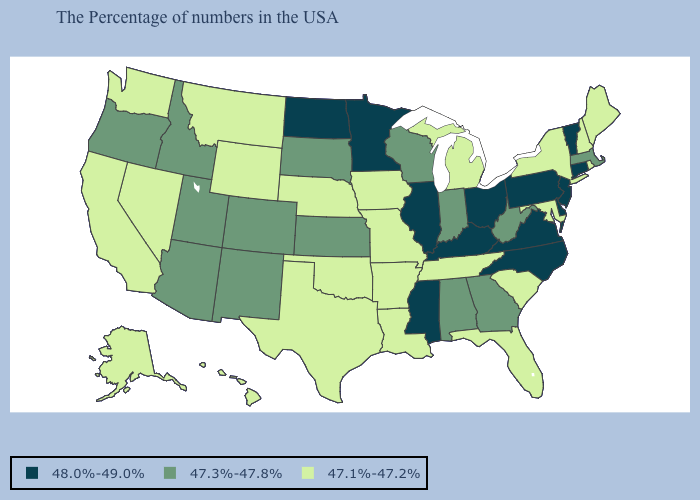Does Indiana have the highest value in the MidWest?
Be succinct. No. What is the value of New Jersey?
Short answer required. 48.0%-49.0%. Does the first symbol in the legend represent the smallest category?
Be succinct. No. What is the value of Tennessee?
Short answer required. 47.1%-47.2%. Among the states that border Alabama , does Mississippi have the highest value?
Short answer required. Yes. What is the value of Missouri?
Answer briefly. 47.1%-47.2%. Which states have the lowest value in the USA?
Quick response, please. Maine, Rhode Island, New Hampshire, New York, Maryland, South Carolina, Florida, Michigan, Tennessee, Louisiana, Missouri, Arkansas, Iowa, Nebraska, Oklahoma, Texas, Wyoming, Montana, Nevada, California, Washington, Alaska, Hawaii. Does North Dakota have the highest value in the USA?
Answer briefly. Yes. What is the value of Delaware?
Keep it brief. 48.0%-49.0%. Name the states that have a value in the range 47.1%-47.2%?
Concise answer only. Maine, Rhode Island, New Hampshire, New York, Maryland, South Carolina, Florida, Michigan, Tennessee, Louisiana, Missouri, Arkansas, Iowa, Nebraska, Oklahoma, Texas, Wyoming, Montana, Nevada, California, Washington, Alaska, Hawaii. What is the value of West Virginia?
Answer briefly. 47.3%-47.8%. Does New York have a lower value than Ohio?
Keep it brief. Yes. Name the states that have a value in the range 47.3%-47.8%?
Give a very brief answer. Massachusetts, West Virginia, Georgia, Indiana, Alabama, Wisconsin, Kansas, South Dakota, Colorado, New Mexico, Utah, Arizona, Idaho, Oregon. Does Minnesota have the lowest value in the USA?
Concise answer only. No. 